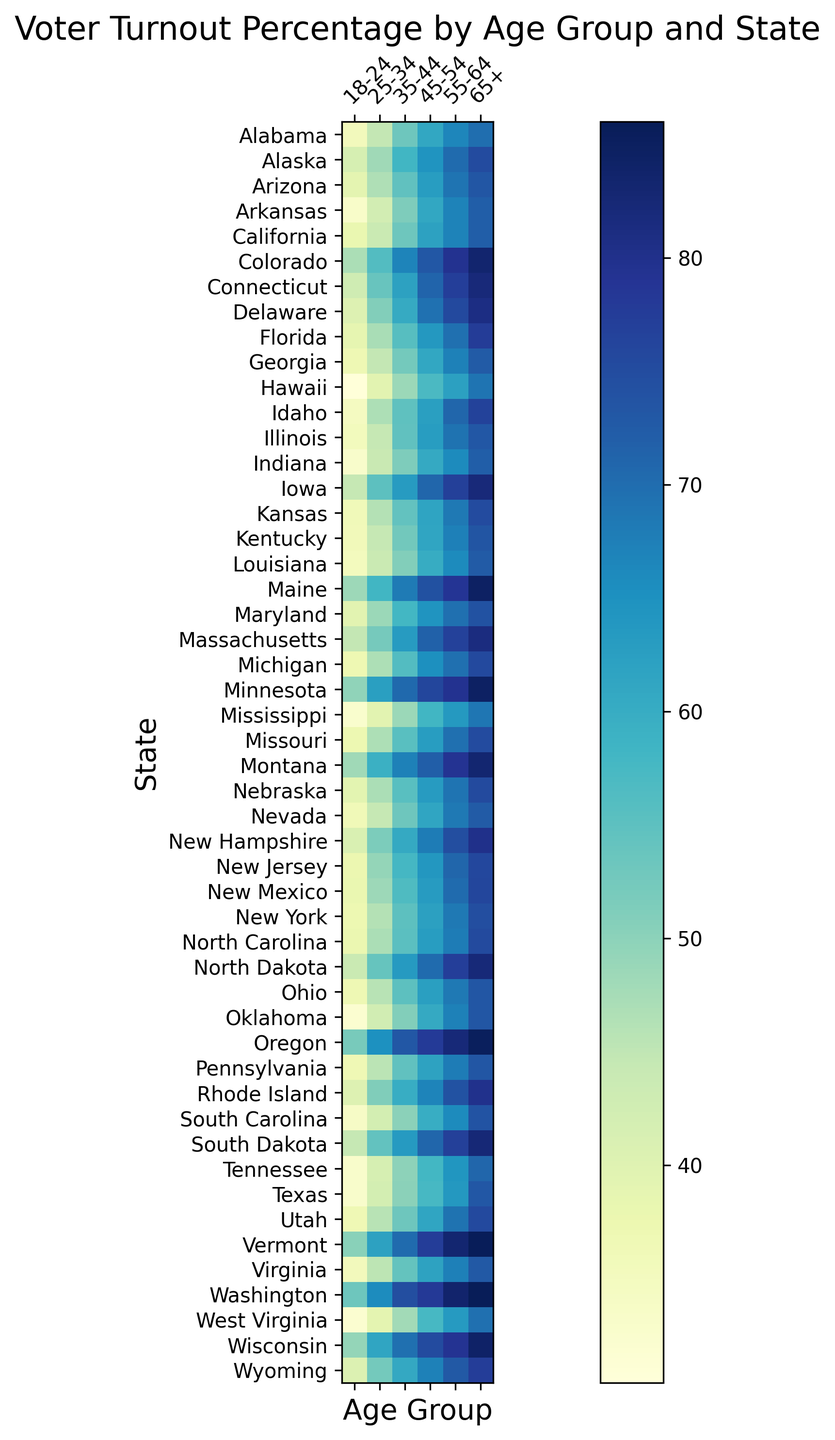What age group in Oregon has the highest voter turnout percentage? In the heatmap, look at the column for Oregon and identify the cell with the darkest color (which represents the highest percentage). The age group "65+" is the darkest.
Answer: 65+ Which state has the lowest voter turnout percentage for the 18-24 age group? In the heatmap, look at the row for the 18-24 age group and find the cell with the lightest color (which represents the lowest percentage), which is Hawaii.
Answer: Hawaii What is the difference in voter turnout percentage between the 25-34 and 55-64 age groups in California? Identify the cells for California in the columns for ages 25-34 and 55-64. The values are 43.8% and 66.9% respectively. Subtract 43.8 from 66.9 to get the difference.
Answer: 23.1 Which state has the most consistent voter turnout percentages across all age groups? Consistency means smaller variations in color intensity across all age groups. Identify the state with similar shades/colors across columns, which appears to be Minnesota.
Answer: Minnesota What is the average voter turnout percentage for the 45-54 age group in the New England states (Connecticut, Maine, Massachusetts, New Hampshire, Rhode Island, Vermont)? Look at the values for the 45-54 age group in these states: Connecticut (71.1), Maine (74.2), Massachusetts (71.5), New Hampshire (67.9), Rhode Island (66.8), Vermont (77.5). Calculate the average: (71.1 + 74.2 + 71.5 + 67.9 + 66.8 + 77.5)/6.
Answer: 71.5 Which age group has the most variation in voter turnout percentages across all states? Look at each age group's column and identify which column has the greatest range of colors from light to dark, suggesting the most variation. The 18-24 age group shows the most variation.
Answer: 18-24 How does the voter turnout for the 65+ age group in Texas compare to the 35-44 age group in New York? Find the values for Texas (65+) and New York (35-44): Texas (65+) is 73.0 and New York (35-44) is 55.1. Compare 73.0 to 55.1; 73.0 is higher.
Answer: Higher Which age group in Washington has the highest voter turnout? Look at the column for Washington and identify the darkest cell representing the highest percentage. The 65+ age group is the darkest.
Answer: 65+ Is the voter turnout percentage for the 25-34 age group in Wyoming closer to the voter turnout for the 35-44 age group in Alabama or the 18-24 age group in Florida? Compare the values: Wyoming (25-34) is 52.5, Alabama (35-44) is 53.2, Florida (18-24) is 38.6. Calculate the differences:
Answer: Closer to Alabama (53.2) Which state has the highest voter turnout percentage for the 55-64 age group, and what is that percentage? Look for the darkest cell in the column for the 55-64 age group. The darkest color is in Washington, with a value of 83.5%.
Answer: Washington, 83.5% 